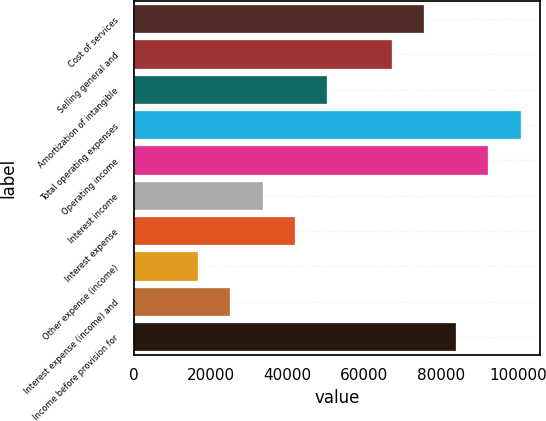Convert chart. <chart><loc_0><loc_0><loc_500><loc_500><bar_chart><fcel>Cost of services<fcel>Selling general and<fcel>Amortization of intangible<fcel>Total operating expenses<fcel>Operating income<fcel>Interest income<fcel>Interest expense<fcel>Other expense (income)<fcel>Interest expense (income) and<fcel>Income before provision for<nl><fcel>75510<fcel>67120<fcel>50340.1<fcel>100680<fcel>92290<fcel>33560.2<fcel>41950.1<fcel>16780.2<fcel>25170.2<fcel>83900<nl></chart> 